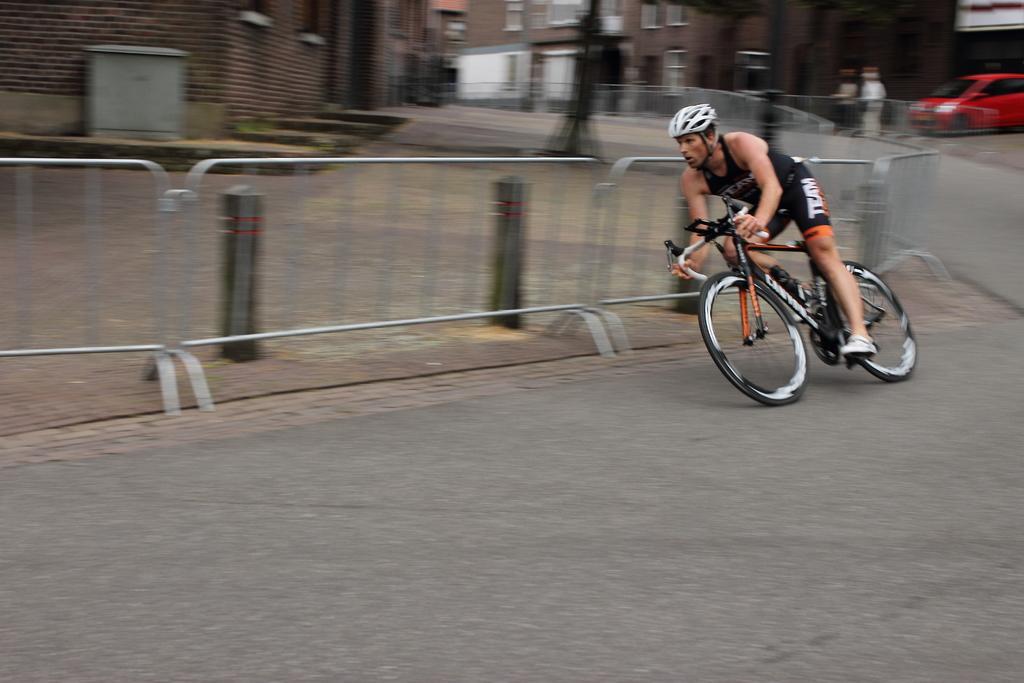How would you summarize this image in a sentence or two? In the image there is a man riding a cycle on the road, behind him there are buildings, fencing, a car and two other people. 